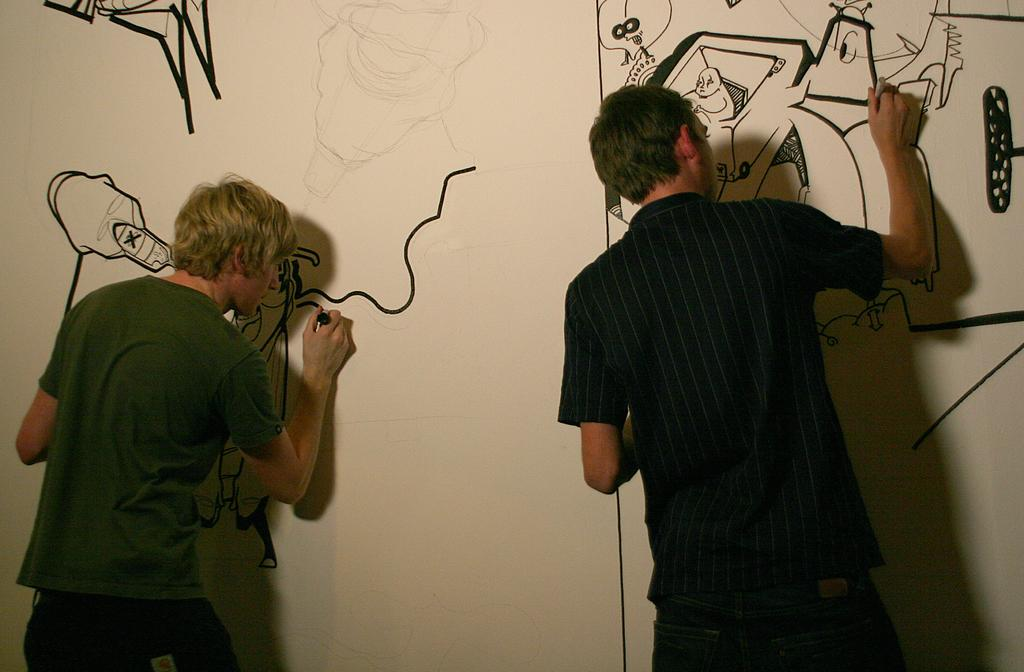How many people are present in the image? There are two persons in the image. What are the two persons doing in the image? The two persons are drawing sketches. Where are the sketches being drawn? The sketches are being drawn on a wall. Can you see any rays emanating from the sketches on the wall? There are no rays visible in the image; it features two persons drawing sketches on a wall. Are there any snails present in the image? There are no snails present in the image. 